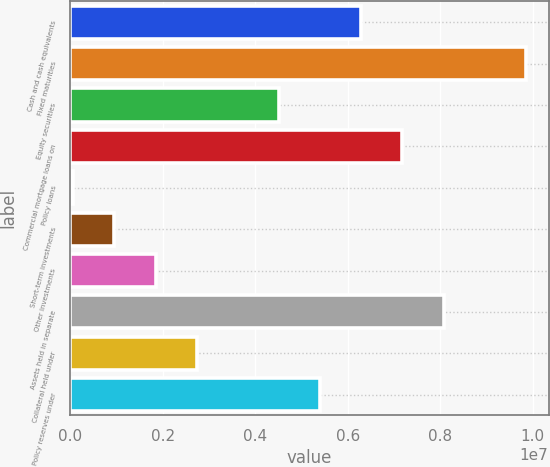Convert chart. <chart><loc_0><loc_0><loc_500><loc_500><bar_chart><fcel>Cash and cash equivalents<fcel>Fixed maturities<fcel>Equity securities<fcel>Commercial mortgage loans on<fcel>Policy loans<fcel>Short-term investments<fcel>Other investments<fcel>Assets held in separate<fcel>Collateral held under<fcel>Policy reserves under<nl><fcel>6.29156e+06<fcel>9.85185e+06<fcel>4.51141e+06<fcel>7.18163e+06<fcel>61043<fcel>951116<fcel>1.84119e+06<fcel>8.0717e+06<fcel>2.73126e+06<fcel>5.40148e+06<nl></chart> 